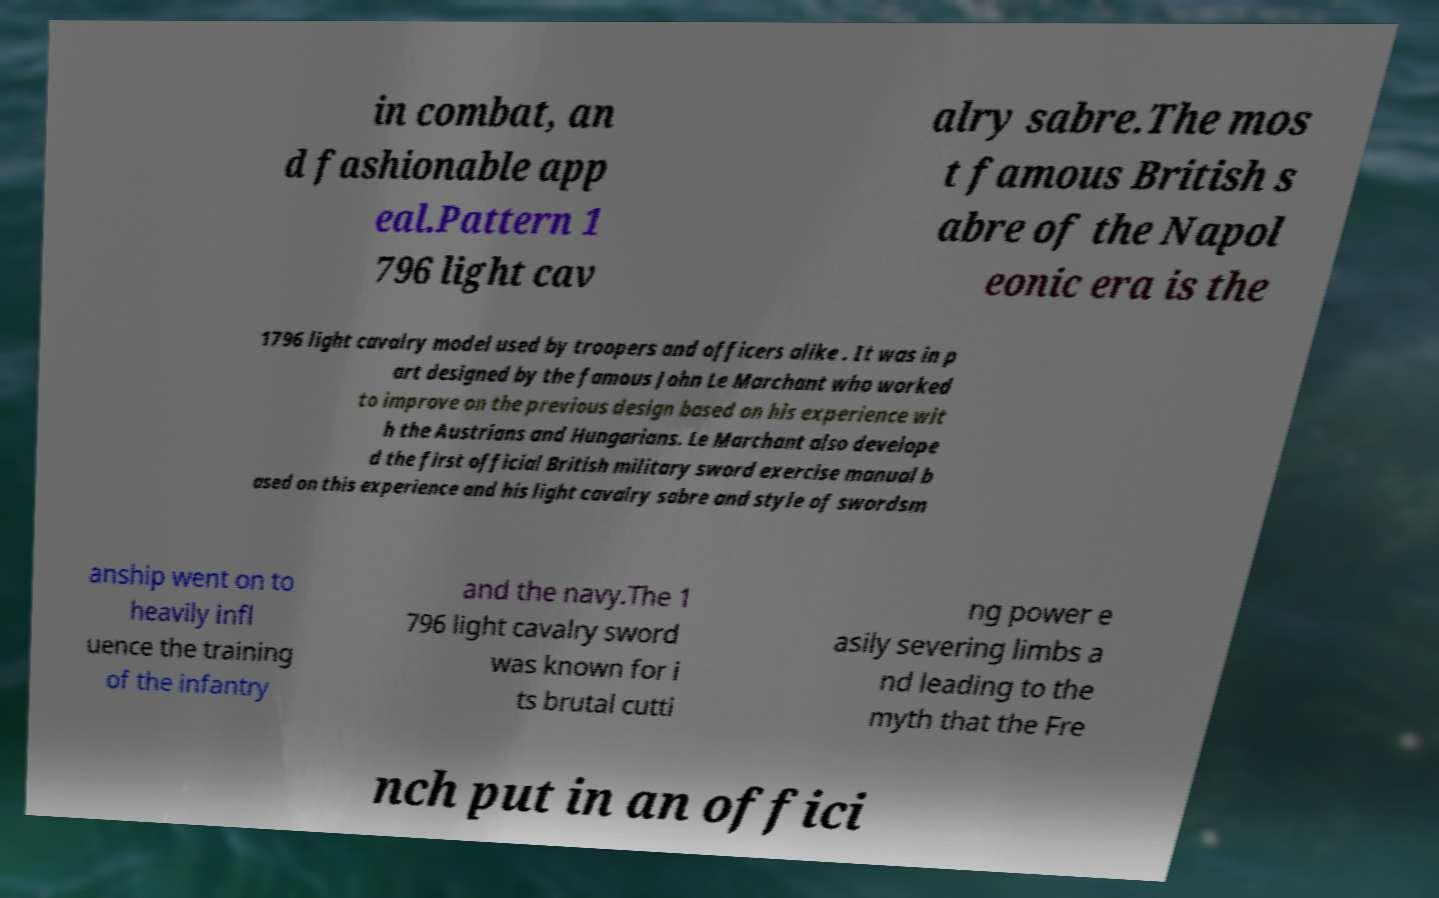I need the written content from this picture converted into text. Can you do that? in combat, an d fashionable app eal.Pattern 1 796 light cav alry sabre.The mos t famous British s abre of the Napol eonic era is the 1796 light cavalry model used by troopers and officers alike . It was in p art designed by the famous John Le Marchant who worked to improve on the previous design based on his experience wit h the Austrians and Hungarians. Le Marchant also develope d the first official British military sword exercise manual b ased on this experience and his light cavalry sabre and style of swordsm anship went on to heavily infl uence the training of the infantry and the navy.The 1 796 light cavalry sword was known for i ts brutal cutti ng power e asily severing limbs a nd leading to the myth that the Fre nch put in an offici 